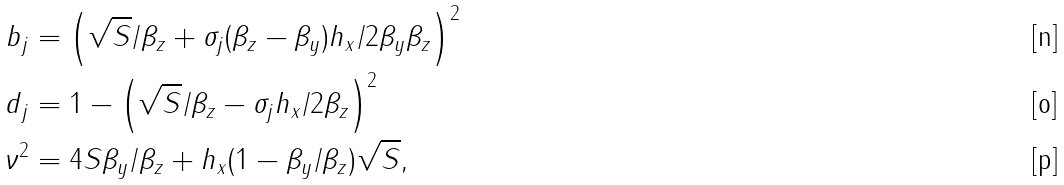Convert formula to latex. <formula><loc_0><loc_0><loc_500><loc_500>b _ { j } & = \left ( \sqrt { S } / \beta _ { z } + \sigma _ { j } ( \beta _ { z } - \beta _ { y } ) h _ { x } / 2 \beta _ { y } \beta _ { z } \right ) ^ { 2 } \\ d _ { j } & = 1 - \left ( \sqrt { S } / \beta _ { z } - \sigma _ { j } h _ { x } / 2 \beta _ { z } \right ) ^ { 2 } \\ \nu ^ { 2 } & = 4 S \beta _ { y } / \beta _ { z } + h _ { x } ( 1 - \beta _ { y } / \beta _ { z } ) \sqrt { S } ,</formula> 